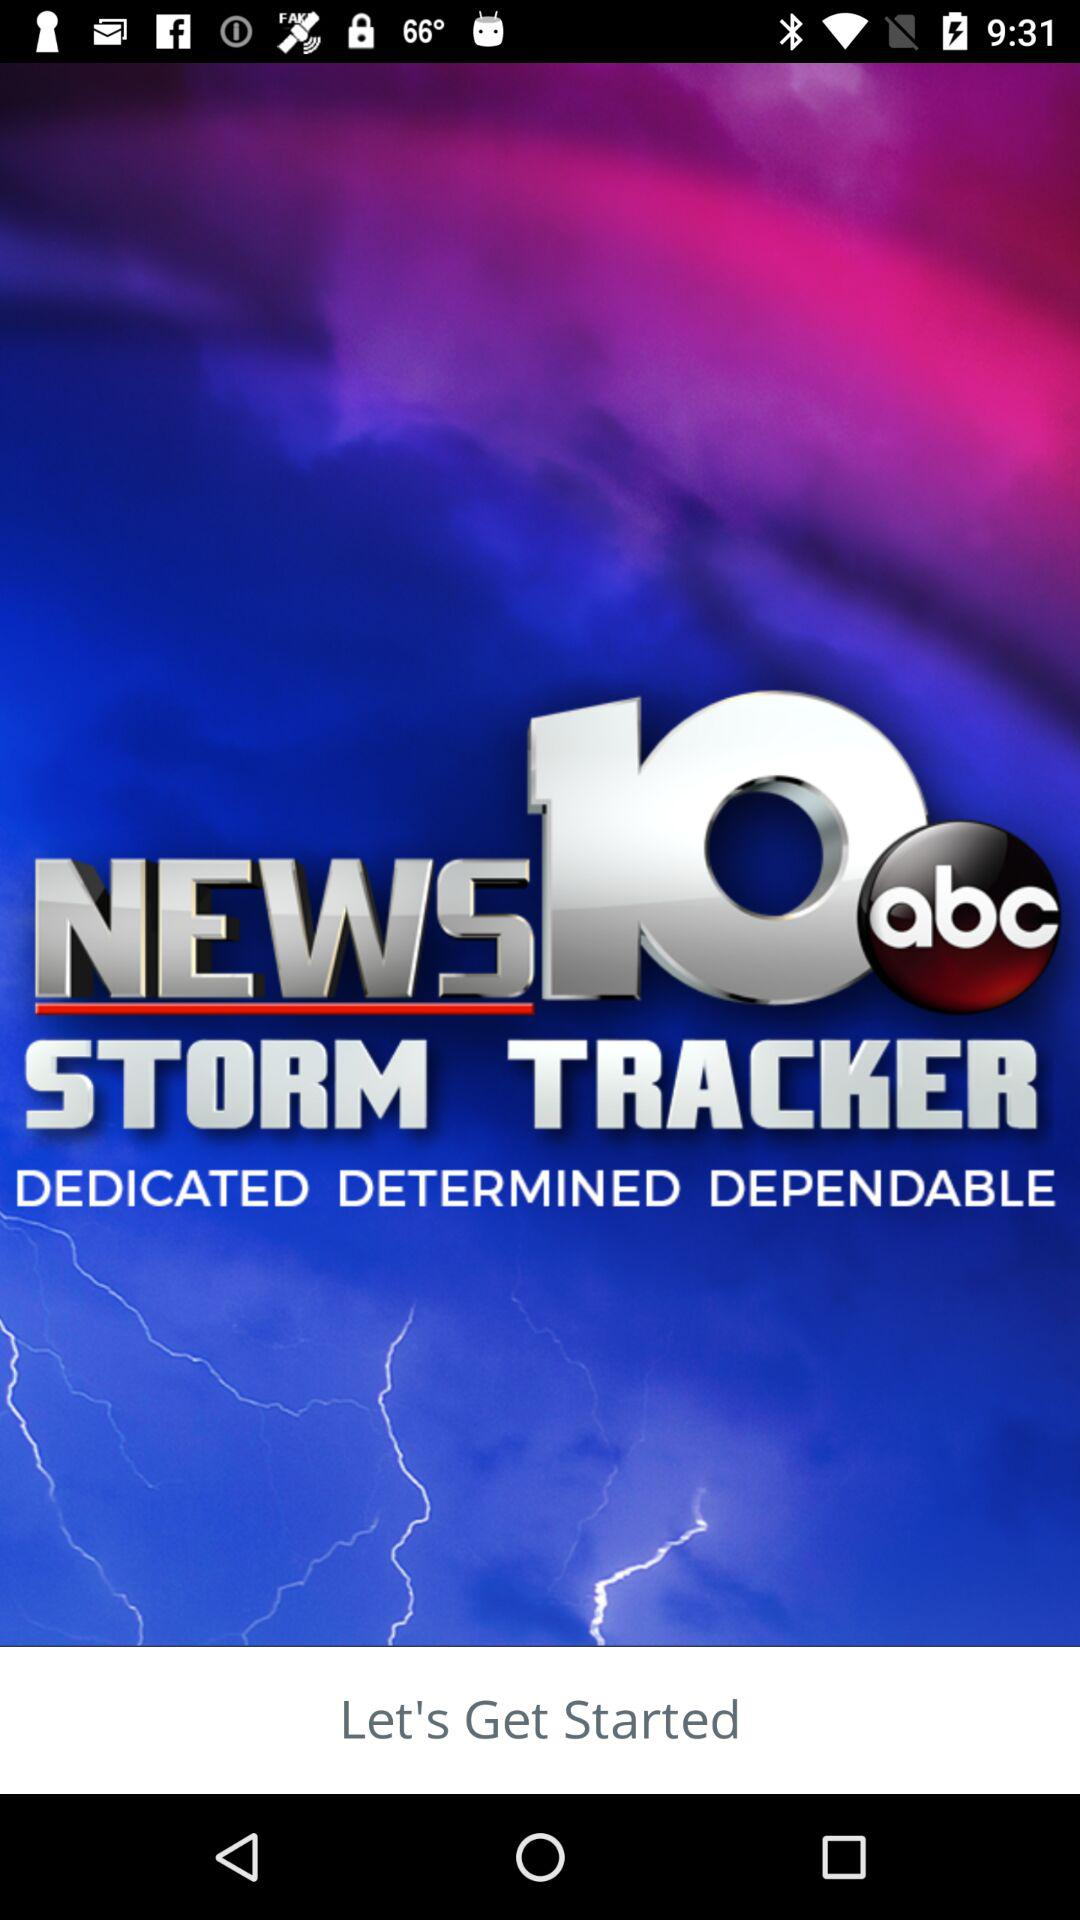What is the name of the application? The name of the application is "WTEN Storm Tracker - NEWS10". 